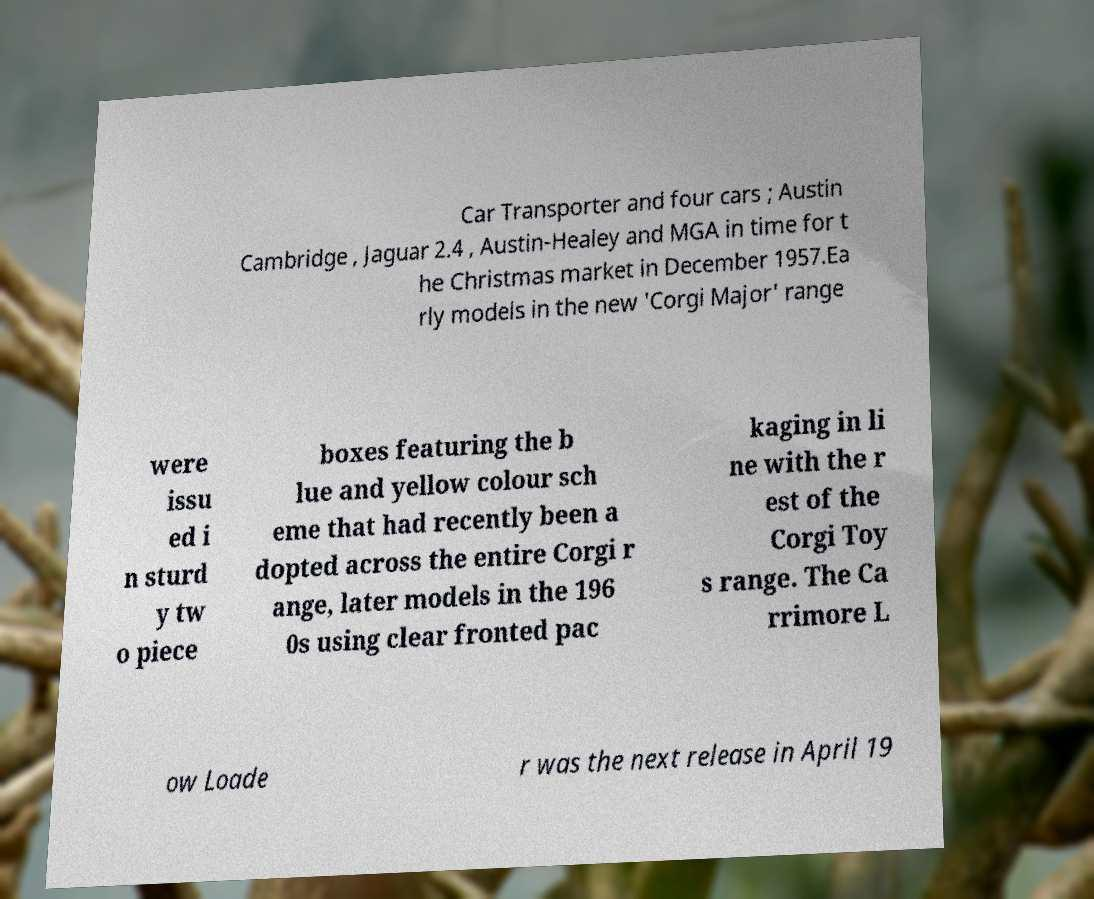There's text embedded in this image that I need extracted. Can you transcribe it verbatim? Car Transporter and four cars ; Austin Cambridge , Jaguar 2.4 , Austin-Healey and MGA in time for t he Christmas market in December 1957.Ea rly models in the new 'Corgi Major' range were issu ed i n sturd y tw o piece boxes featuring the b lue and yellow colour sch eme that had recently been a dopted across the entire Corgi r ange, later models in the 196 0s using clear fronted pac kaging in li ne with the r est of the Corgi Toy s range. The Ca rrimore L ow Loade r was the next release in April 19 